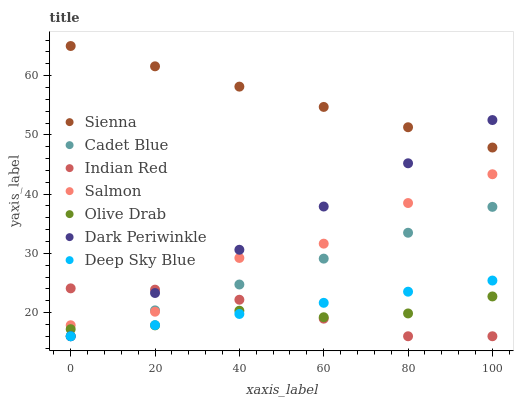Does Olive Drab have the minimum area under the curve?
Answer yes or no. Yes. Does Sienna have the maximum area under the curve?
Answer yes or no. Yes. Does Deep Sky Blue have the minimum area under the curve?
Answer yes or no. No. Does Deep Sky Blue have the maximum area under the curve?
Answer yes or no. No. Is Deep Sky Blue the smoothest?
Answer yes or no. Yes. Is Salmon the roughest?
Answer yes or no. Yes. Is Salmon the smoothest?
Answer yes or no. No. Is Deep Sky Blue the roughest?
Answer yes or no. No. Does Cadet Blue have the lowest value?
Answer yes or no. Yes. Does Salmon have the lowest value?
Answer yes or no. No. Does Sienna have the highest value?
Answer yes or no. Yes. Does Deep Sky Blue have the highest value?
Answer yes or no. No. Is Olive Drab less than Sienna?
Answer yes or no. Yes. Is Sienna greater than Salmon?
Answer yes or no. Yes. Does Olive Drab intersect Deep Sky Blue?
Answer yes or no. Yes. Is Olive Drab less than Deep Sky Blue?
Answer yes or no. No. Is Olive Drab greater than Deep Sky Blue?
Answer yes or no. No. Does Olive Drab intersect Sienna?
Answer yes or no. No. 